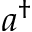<formula> <loc_0><loc_0><loc_500><loc_500>a ^ { \dagger }</formula> 